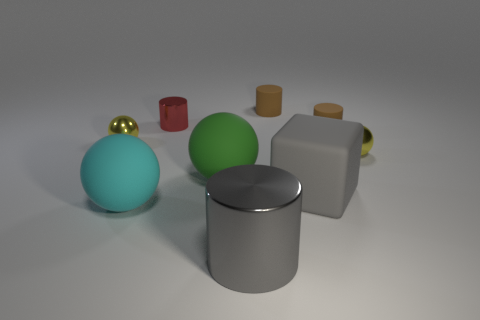What number of other things are there of the same size as the green ball?
Make the answer very short. 3. There is a matte thing that is the same color as the large shiny thing; what is its size?
Offer a terse response. Large. There is a yellow object that is to the right of the small red thing; is it the same shape as the large metallic object?
Keep it short and to the point. No. There is a large sphere behind the cyan matte sphere; what is its material?
Offer a terse response. Rubber. What shape is the large metallic object that is the same color as the big block?
Offer a very short reply. Cylinder. Are there any large cyan spheres that have the same material as the big green thing?
Keep it short and to the point. Yes. The red metallic cylinder has what size?
Ensure brevity in your answer.  Small. How many purple things are either metal cylinders or small shiny spheres?
Provide a succinct answer. 0. How many red metallic things are the same shape as the green matte object?
Your answer should be compact. 0. How many green balls are the same size as the cyan matte object?
Provide a succinct answer. 1. 